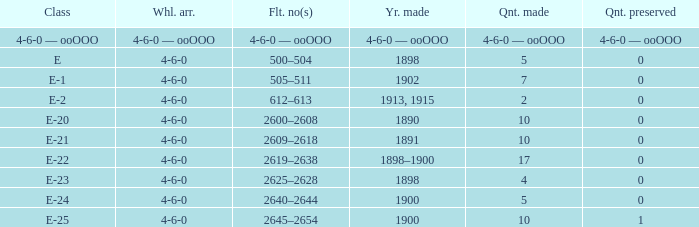What is the wheel setup designed in 1890? 4-6-0. 